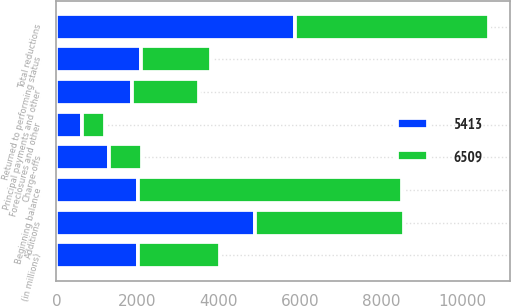<chart> <loc_0><loc_0><loc_500><loc_500><stacked_bar_chart><ecel><fcel>(in millions)<fcel>Beginning balance<fcel>Additions<fcel>Principal payments and other<fcel>Charge-offs<fcel>Returned to performing status<fcel>Foreclosures and other<fcel>Total reductions<nl><fcel>6509<fcel>2015<fcel>6509<fcel>3662<fcel>1668<fcel>800<fcel>1725<fcel>565<fcel>4758<nl><fcel>5413<fcel>2014<fcel>2014<fcel>4905<fcel>1859<fcel>1306<fcel>2083<fcel>644<fcel>5892<nl></chart> 